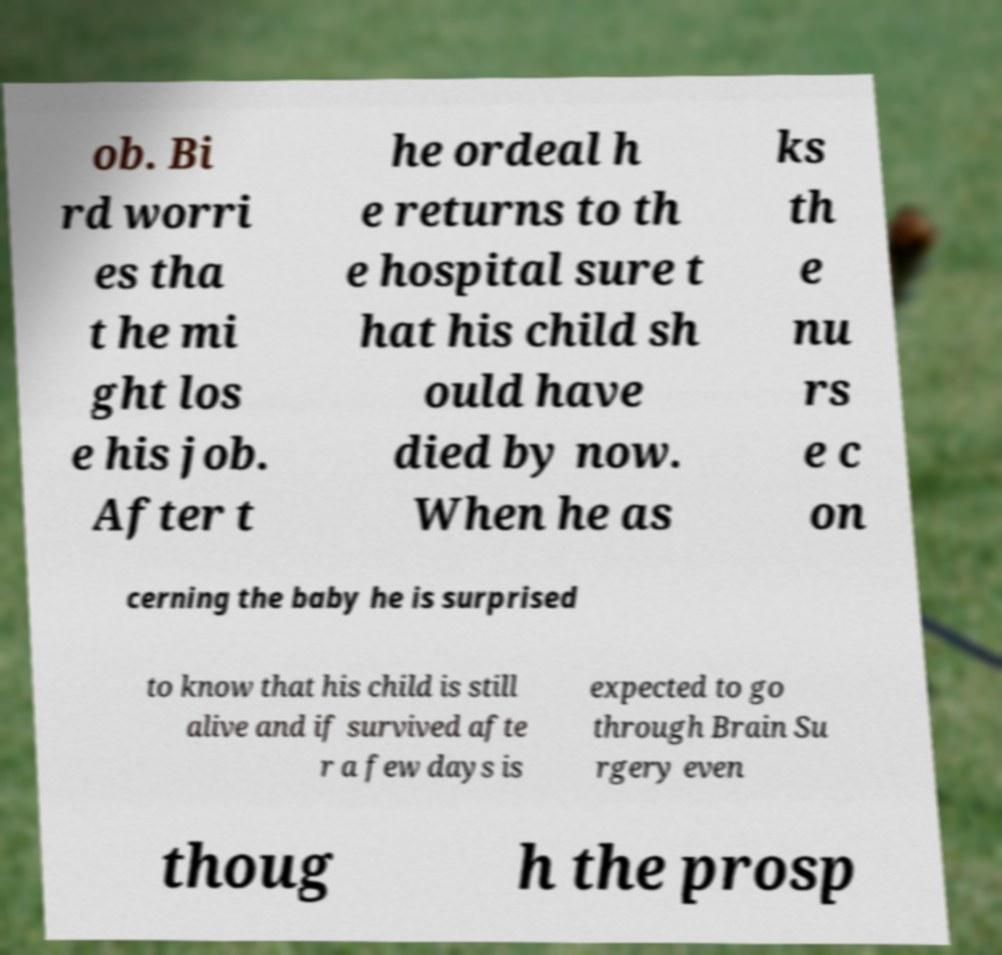Could you assist in decoding the text presented in this image and type it out clearly? ob. Bi rd worri es tha t he mi ght los e his job. After t he ordeal h e returns to th e hospital sure t hat his child sh ould have died by now. When he as ks th e nu rs e c on cerning the baby he is surprised to know that his child is still alive and if survived afte r a few days is expected to go through Brain Su rgery even thoug h the prosp 